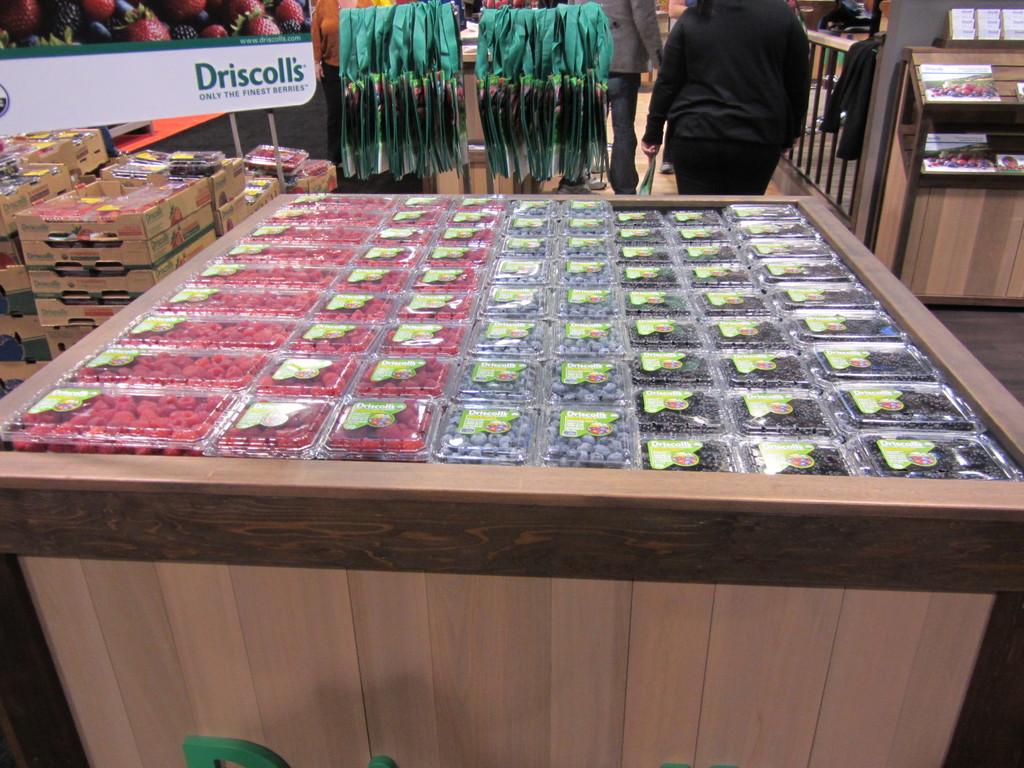What brand of fruit?
Give a very brief answer. Driscoll's. 